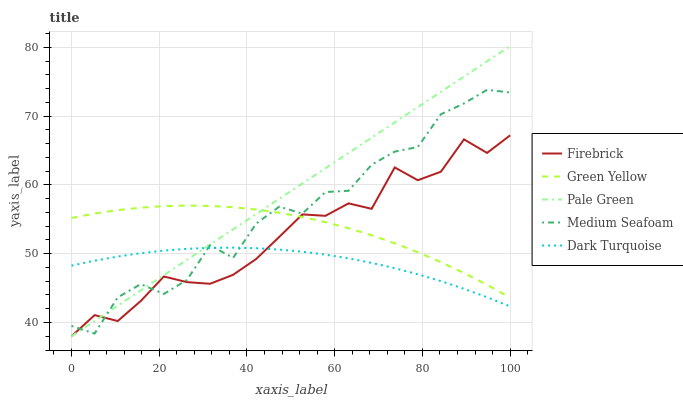Does Dark Turquoise have the minimum area under the curve?
Answer yes or no. Yes. Does Pale Green have the maximum area under the curve?
Answer yes or no. Yes. Does Firebrick have the minimum area under the curve?
Answer yes or no. No. Does Firebrick have the maximum area under the curve?
Answer yes or no. No. Is Pale Green the smoothest?
Answer yes or no. Yes. Is Medium Seafoam the roughest?
Answer yes or no. Yes. Is Firebrick the smoothest?
Answer yes or no. No. Is Firebrick the roughest?
Answer yes or no. No. Does Green Yellow have the lowest value?
Answer yes or no. No. Does Pale Green have the highest value?
Answer yes or no. Yes. Does Firebrick have the highest value?
Answer yes or no. No. Is Dark Turquoise less than Green Yellow?
Answer yes or no. Yes. Is Green Yellow greater than Dark Turquoise?
Answer yes or no. Yes. Does Pale Green intersect Green Yellow?
Answer yes or no. Yes. Is Pale Green less than Green Yellow?
Answer yes or no. No. Is Pale Green greater than Green Yellow?
Answer yes or no. No. Does Dark Turquoise intersect Green Yellow?
Answer yes or no. No. 